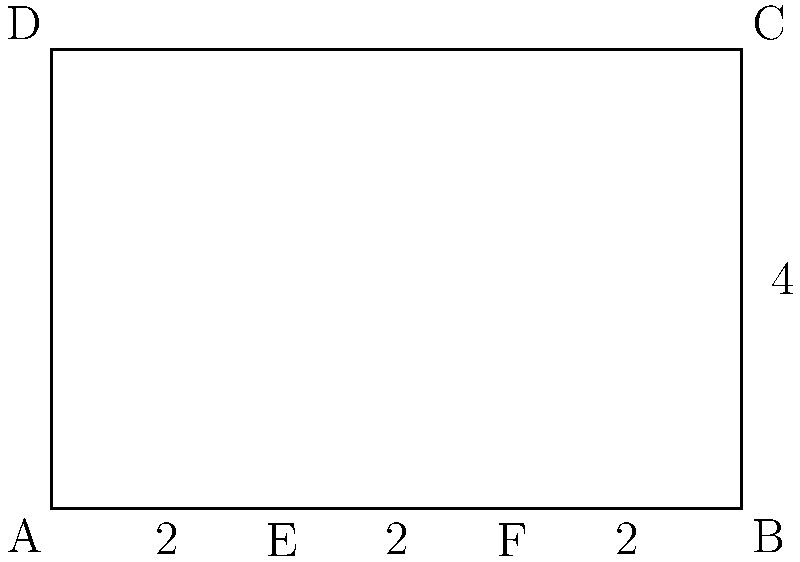In the classical architectural facade shown above, the golden ratio is used to determine the proportions. If the total width of the facade is 6 units and the height is 4 units, what is the length of segment EF to achieve the golden ratio in relation to the entire width AB? To solve this problem, we need to follow these steps:

1. Recall the golden ratio formula: $\frac{a+b}{a} = \frac{a}{b} \approx 1.618$, where $a$ is the longer segment and $b$ is the shorter segment.

2. In this case, AB is the total width (6 units), and we need to find EF.
   Let x be the length of EF. Then:
   $\frac{AB}{EF} = \frac{EF}{AB-EF}$

3. Substituting the known values:
   $\frac{6}{x} = \frac{x}{6-x}$

4. Cross multiply:
   $6(6-x) = x^2$

5. Expand the equation:
   $36 - 6x = x^2$

6. Rearrange to standard quadratic form:
   $x^2 + 6x - 36 = 0$

7. Use the quadratic formula to solve for x:
   $x = \frac{-b \pm \sqrt{b^2 - 4ac}}{2a}$
   $x = \frac{-6 \pm \sqrt{36 + 144}}{2} = \frac{-6 \pm \sqrt{180}}{2}$

8. Simplify:
   $x = \frac{-6 \pm 6\sqrt{5}}{2}$

9. We only need the positive solution:
   $x = \frac{-6 + 6\sqrt{5}}{2} = 3(\sqrt{5} - 1) \approx 3.708$

Therefore, the length of segment EF should be approximately 3.708 units to achieve the golden ratio in relation to the entire width AB.
Answer: $3(\sqrt{5} - 1)$ units 